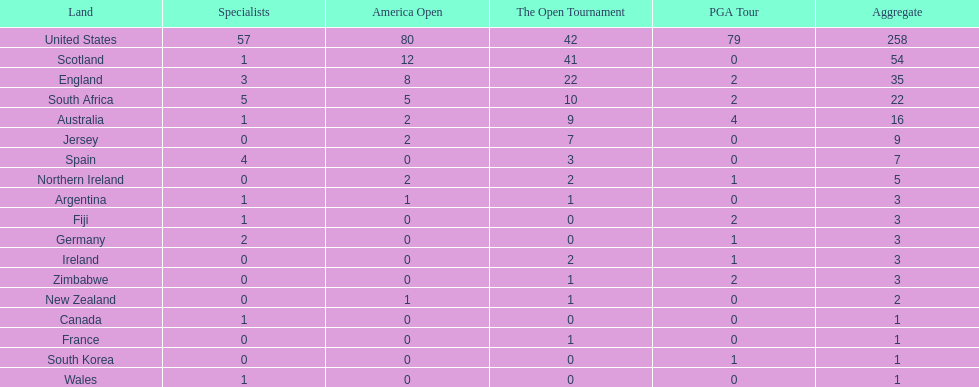What are the number of pga winning golfers that zimbabwe has? 2. 